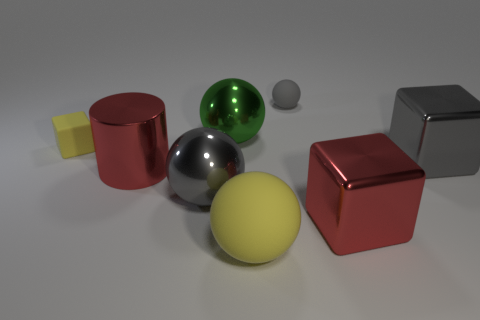Subtract 1 spheres. How many spheres are left? 3 Add 1 yellow matte blocks. How many objects exist? 9 Subtract all blocks. How many objects are left? 5 Subtract 0 cyan cylinders. How many objects are left? 8 Subtract all red metallic balls. Subtract all tiny gray rubber balls. How many objects are left? 7 Add 3 large gray objects. How many large gray objects are left? 5 Add 4 gray matte balls. How many gray matte balls exist? 5 